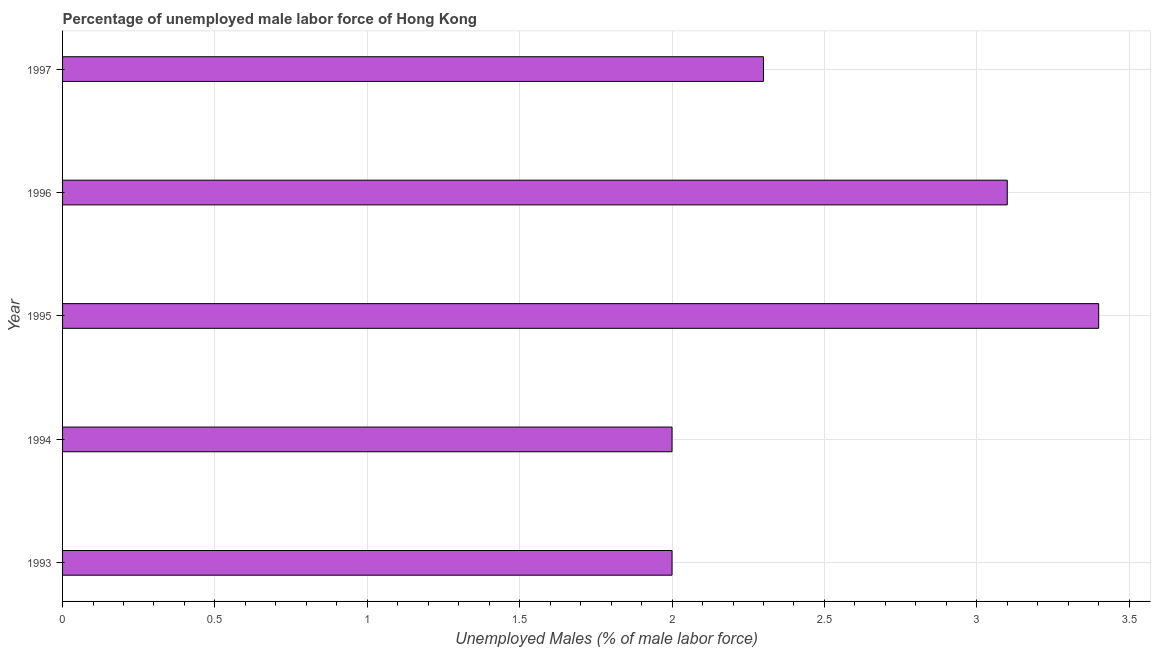Does the graph contain any zero values?
Offer a terse response. No. What is the title of the graph?
Give a very brief answer. Percentage of unemployed male labor force of Hong Kong. What is the label or title of the X-axis?
Your answer should be very brief. Unemployed Males (% of male labor force). What is the label or title of the Y-axis?
Keep it short and to the point. Year. What is the total unemployed male labour force in 1996?
Ensure brevity in your answer.  3.1. Across all years, what is the maximum total unemployed male labour force?
Ensure brevity in your answer.  3.4. In which year was the total unemployed male labour force maximum?
Provide a succinct answer. 1995. What is the sum of the total unemployed male labour force?
Your response must be concise. 12.8. What is the difference between the total unemployed male labour force in 1993 and 1997?
Keep it short and to the point. -0.3. What is the average total unemployed male labour force per year?
Your answer should be compact. 2.56. What is the median total unemployed male labour force?
Your response must be concise. 2.3. In how many years, is the total unemployed male labour force greater than 2.5 %?
Offer a terse response. 2. Do a majority of the years between 1993 and 1997 (inclusive) have total unemployed male labour force greater than 0.8 %?
Offer a terse response. Yes. What is the ratio of the total unemployed male labour force in 1996 to that in 1997?
Provide a succinct answer. 1.35. Is the total unemployed male labour force in 1993 less than that in 1997?
Give a very brief answer. Yes. Is the difference between the total unemployed male labour force in 1995 and 1996 greater than the difference between any two years?
Your response must be concise. No. Is the sum of the total unemployed male labour force in 1996 and 1997 greater than the maximum total unemployed male labour force across all years?
Your answer should be compact. Yes. How many bars are there?
Your response must be concise. 5. Are all the bars in the graph horizontal?
Ensure brevity in your answer.  Yes. What is the difference between two consecutive major ticks on the X-axis?
Make the answer very short. 0.5. Are the values on the major ticks of X-axis written in scientific E-notation?
Make the answer very short. No. What is the Unemployed Males (% of male labor force) of 1993?
Provide a succinct answer. 2. What is the Unemployed Males (% of male labor force) of 1995?
Ensure brevity in your answer.  3.4. What is the Unemployed Males (% of male labor force) in 1996?
Ensure brevity in your answer.  3.1. What is the Unemployed Males (% of male labor force) of 1997?
Ensure brevity in your answer.  2.3. What is the difference between the Unemployed Males (% of male labor force) in 1993 and 1994?
Offer a very short reply. 0. What is the difference between the Unemployed Males (% of male labor force) in 1993 and 1996?
Provide a succinct answer. -1.1. What is the difference between the Unemployed Males (% of male labor force) in 1993 and 1997?
Your answer should be compact. -0.3. What is the difference between the Unemployed Males (% of male labor force) in 1995 and 1996?
Keep it short and to the point. 0.3. What is the ratio of the Unemployed Males (% of male labor force) in 1993 to that in 1994?
Provide a short and direct response. 1. What is the ratio of the Unemployed Males (% of male labor force) in 1993 to that in 1995?
Give a very brief answer. 0.59. What is the ratio of the Unemployed Males (% of male labor force) in 1993 to that in 1996?
Give a very brief answer. 0.65. What is the ratio of the Unemployed Males (% of male labor force) in 1993 to that in 1997?
Your answer should be very brief. 0.87. What is the ratio of the Unemployed Males (% of male labor force) in 1994 to that in 1995?
Make the answer very short. 0.59. What is the ratio of the Unemployed Males (% of male labor force) in 1994 to that in 1996?
Make the answer very short. 0.65. What is the ratio of the Unemployed Males (% of male labor force) in 1994 to that in 1997?
Provide a short and direct response. 0.87. What is the ratio of the Unemployed Males (% of male labor force) in 1995 to that in 1996?
Offer a terse response. 1.1. What is the ratio of the Unemployed Males (% of male labor force) in 1995 to that in 1997?
Offer a very short reply. 1.48. What is the ratio of the Unemployed Males (% of male labor force) in 1996 to that in 1997?
Offer a terse response. 1.35. 